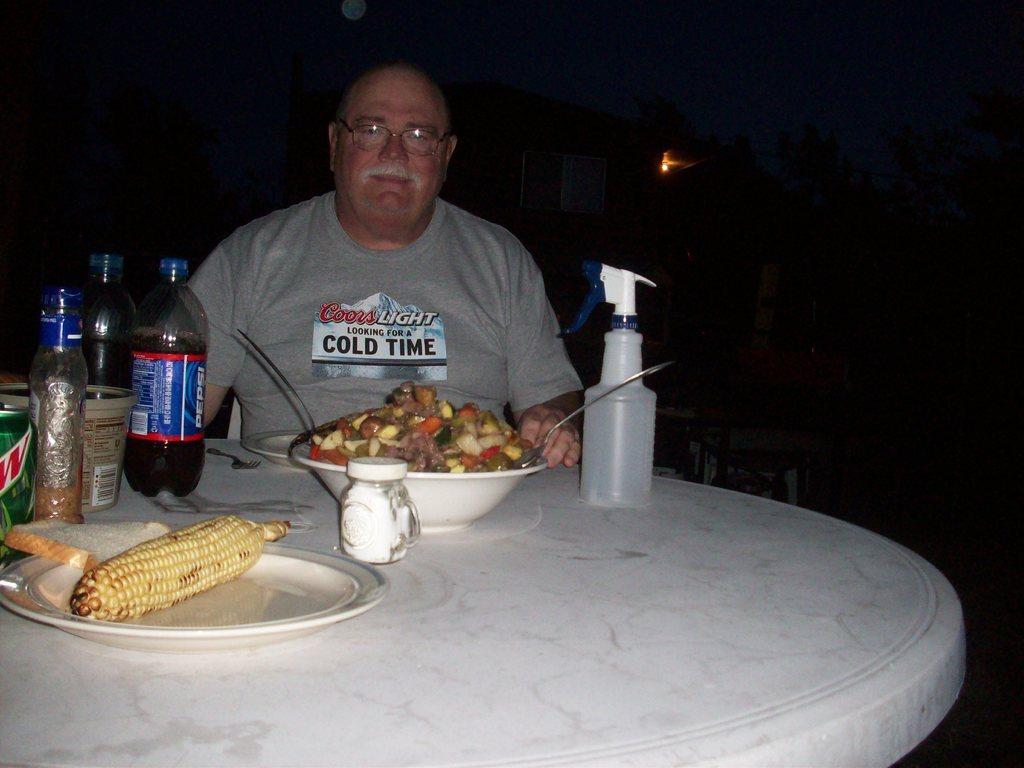In one or two sentences, can you explain what this image depicts? In this image I can see a person wearing grey colored dress is sitting on a chair in front of a white colored table. On the table I can see few plates, a bowl with food item in it, few bottles and a corn in the plate. In the background I can see a building, few trees, the dark sky and the moon. 